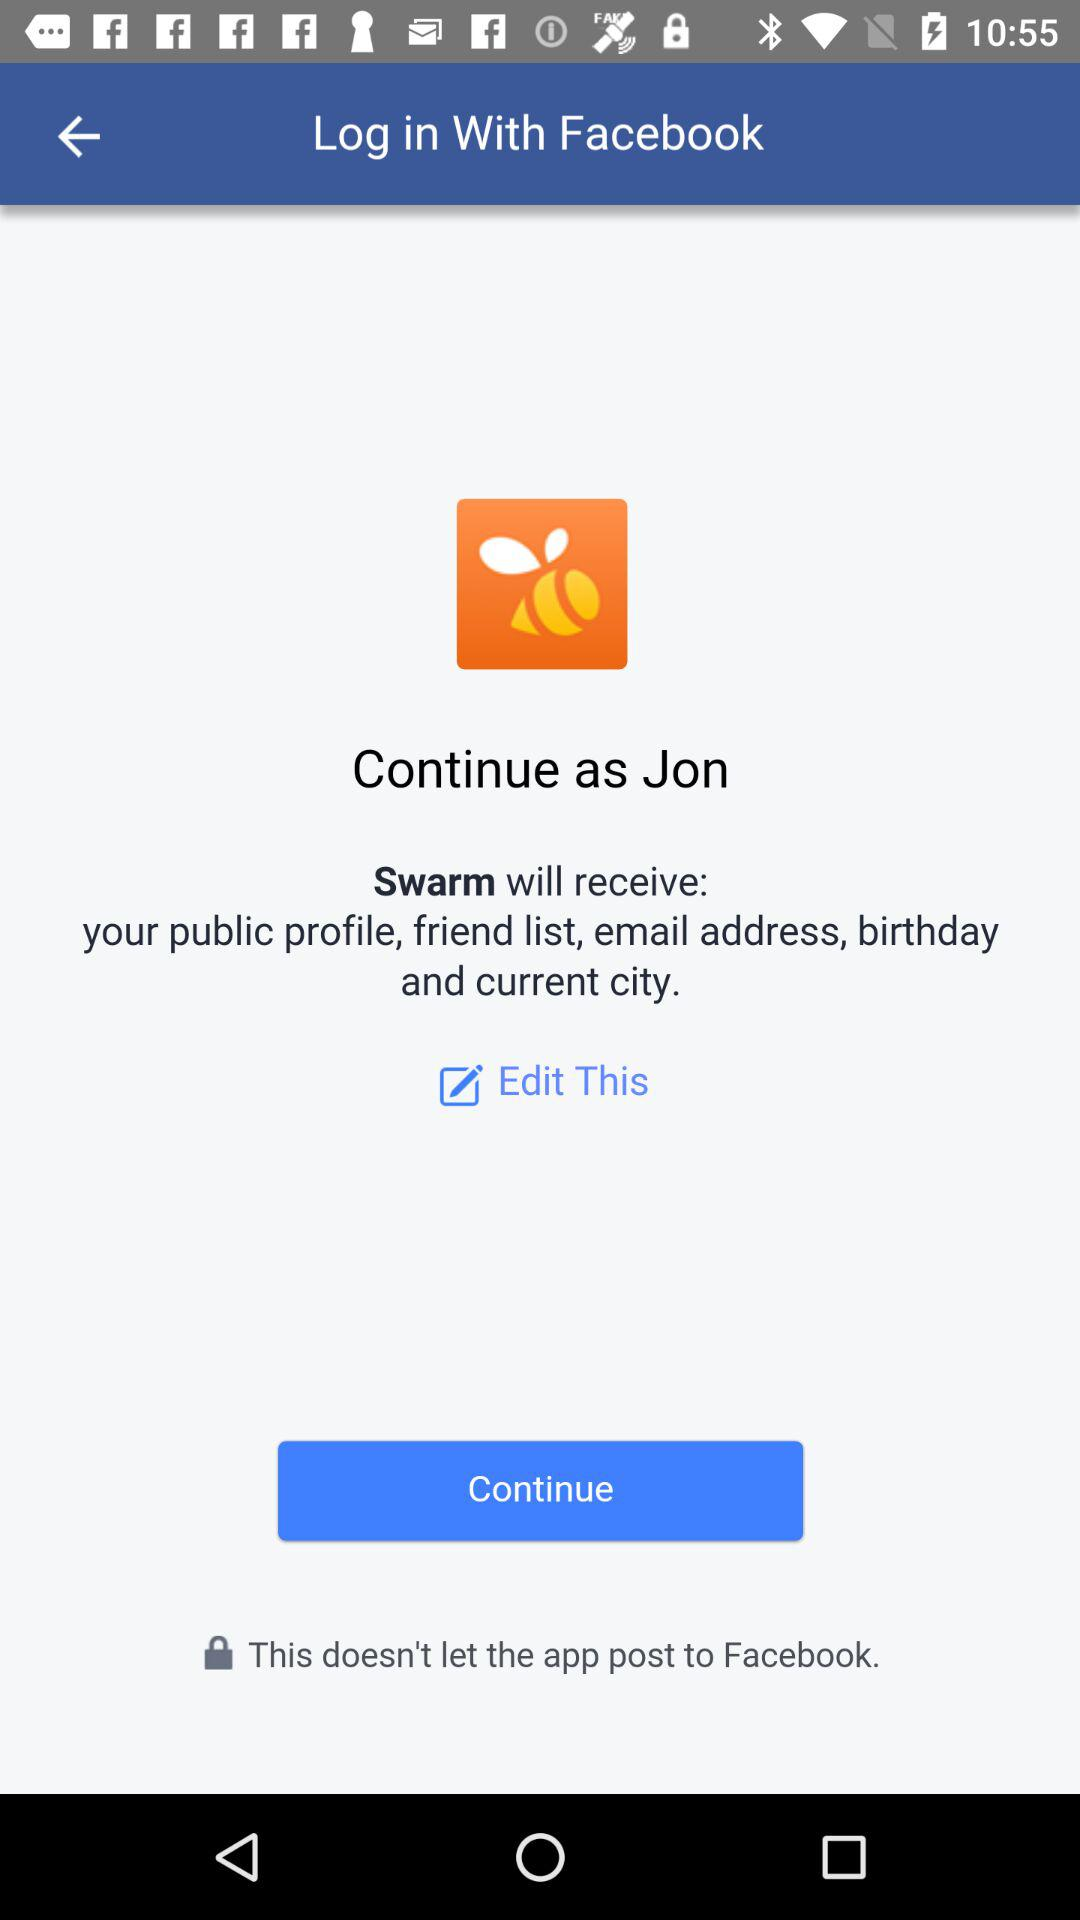What is the name of the user? The name of the user is Jon. 